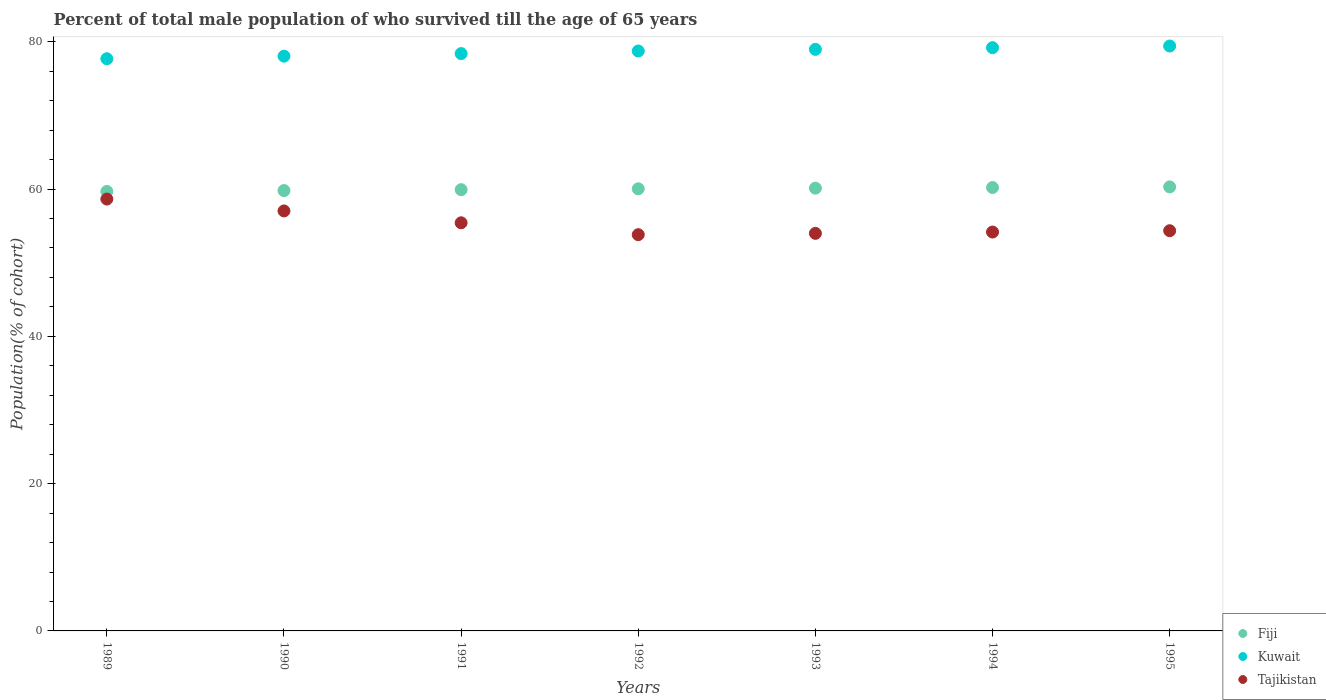How many different coloured dotlines are there?
Offer a very short reply. 3. Is the number of dotlines equal to the number of legend labels?
Your answer should be very brief. Yes. What is the percentage of total male population who survived till the age of 65 years in Kuwait in 1990?
Provide a succinct answer. 78.04. Across all years, what is the maximum percentage of total male population who survived till the age of 65 years in Kuwait?
Your answer should be compact. 79.42. Across all years, what is the minimum percentage of total male population who survived till the age of 65 years in Tajikistan?
Your answer should be compact. 53.8. In which year was the percentage of total male population who survived till the age of 65 years in Kuwait maximum?
Provide a succinct answer. 1995. What is the total percentage of total male population who survived till the age of 65 years in Kuwait in the graph?
Your answer should be compact. 550.42. What is the difference between the percentage of total male population who survived till the age of 65 years in Tajikistan in 1989 and that in 1992?
Ensure brevity in your answer.  4.84. What is the difference between the percentage of total male population who survived till the age of 65 years in Tajikistan in 1992 and the percentage of total male population who survived till the age of 65 years in Fiji in 1995?
Keep it short and to the point. -6.49. What is the average percentage of total male population who survived till the age of 65 years in Kuwait per year?
Offer a very short reply. 78.63. In the year 1989, what is the difference between the percentage of total male population who survived till the age of 65 years in Kuwait and percentage of total male population who survived till the age of 65 years in Fiji?
Your answer should be very brief. 18.02. What is the ratio of the percentage of total male population who survived till the age of 65 years in Tajikistan in 1989 to that in 1994?
Provide a succinct answer. 1.08. Is the difference between the percentage of total male population who survived till the age of 65 years in Kuwait in 1992 and 1993 greater than the difference between the percentage of total male population who survived till the age of 65 years in Fiji in 1992 and 1993?
Your answer should be compact. No. What is the difference between the highest and the second highest percentage of total male population who survived till the age of 65 years in Tajikistan?
Offer a very short reply. 1.61. What is the difference between the highest and the lowest percentage of total male population who survived till the age of 65 years in Fiji?
Your answer should be very brief. 0.62. In how many years, is the percentage of total male population who survived till the age of 65 years in Tajikistan greater than the average percentage of total male population who survived till the age of 65 years in Tajikistan taken over all years?
Ensure brevity in your answer.  3. Is the sum of the percentage of total male population who survived till the age of 65 years in Tajikistan in 1989 and 1993 greater than the maximum percentage of total male population who survived till the age of 65 years in Kuwait across all years?
Your response must be concise. Yes. Is the percentage of total male population who survived till the age of 65 years in Kuwait strictly greater than the percentage of total male population who survived till the age of 65 years in Fiji over the years?
Provide a short and direct response. Yes. How many dotlines are there?
Your answer should be compact. 3. Does the graph contain grids?
Offer a terse response. No. What is the title of the graph?
Offer a very short reply. Percent of total male population of who survived till the age of 65 years. What is the label or title of the Y-axis?
Give a very brief answer. Population(% of cohort). What is the Population(% of cohort) in Fiji in 1989?
Your answer should be very brief. 59.67. What is the Population(% of cohort) in Kuwait in 1989?
Offer a very short reply. 77.69. What is the Population(% of cohort) in Tajikistan in 1989?
Your response must be concise. 58.64. What is the Population(% of cohort) in Fiji in 1990?
Offer a very short reply. 59.79. What is the Population(% of cohort) in Kuwait in 1990?
Ensure brevity in your answer.  78.04. What is the Population(% of cohort) of Tajikistan in 1990?
Your answer should be very brief. 57.02. What is the Population(% of cohort) of Fiji in 1991?
Provide a succinct answer. 59.91. What is the Population(% of cohort) in Kuwait in 1991?
Make the answer very short. 78.39. What is the Population(% of cohort) of Tajikistan in 1991?
Offer a terse response. 55.41. What is the Population(% of cohort) of Fiji in 1992?
Provide a succinct answer. 60.03. What is the Population(% of cohort) in Kuwait in 1992?
Keep it short and to the point. 78.74. What is the Population(% of cohort) of Tajikistan in 1992?
Provide a succinct answer. 53.8. What is the Population(% of cohort) in Fiji in 1993?
Offer a terse response. 60.12. What is the Population(% of cohort) in Kuwait in 1993?
Make the answer very short. 78.96. What is the Population(% of cohort) of Tajikistan in 1993?
Your answer should be compact. 53.98. What is the Population(% of cohort) in Fiji in 1994?
Provide a succinct answer. 60.2. What is the Population(% of cohort) of Kuwait in 1994?
Give a very brief answer. 79.19. What is the Population(% of cohort) of Tajikistan in 1994?
Provide a succinct answer. 54.16. What is the Population(% of cohort) in Fiji in 1995?
Make the answer very short. 60.29. What is the Population(% of cohort) in Kuwait in 1995?
Your answer should be very brief. 79.42. What is the Population(% of cohort) of Tajikistan in 1995?
Ensure brevity in your answer.  54.34. Across all years, what is the maximum Population(% of cohort) in Fiji?
Keep it short and to the point. 60.29. Across all years, what is the maximum Population(% of cohort) in Kuwait?
Your answer should be compact. 79.42. Across all years, what is the maximum Population(% of cohort) in Tajikistan?
Ensure brevity in your answer.  58.64. Across all years, what is the minimum Population(% of cohort) in Fiji?
Provide a short and direct response. 59.67. Across all years, what is the minimum Population(% of cohort) in Kuwait?
Your response must be concise. 77.69. Across all years, what is the minimum Population(% of cohort) in Tajikistan?
Your response must be concise. 53.8. What is the total Population(% of cohort) in Fiji in the graph?
Keep it short and to the point. 420.01. What is the total Population(% of cohort) in Kuwait in the graph?
Offer a very short reply. 550.42. What is the total Population(% of cohort) of Tajikistan in the graph?
Your answer should be very brief. 387.35. What is the difference between the Population(% of cohort) of Fiji in 1989 and that in 1990?
Your answer should be compact. -0.12. What is the difference between the Population(% of cohort) of Kuwait in 1989 and that in 1990?
Your response must be concise. -0.35. What is the difference between the Population(% of cohort) of Tajikistan in 1989 and that in 1990?
Your answer should be very brief. 1.61. What is the difference between the Population(% of cohort) in Fiji in 1989 and that in 1991?
Make the answer very short. -0.24. What is the difference between the Population(% of cohort) in Kuwait in 1989 and that in 1991?
Provide a succinct answer. -0.7. What is the difference between the Population(% of cohort) in Tajikistan in 1989 and that in 1991?
Your response must be concise. 3.22. What is the difference between the Population(% of cohort) in Fiji in 1989 and that in 1992?
Keep it short and to the point. -0.36. What is the difference between the Population(% of cohort) in Kuwait in 1989 and that in 1992?
Provide a short and direct response. -1.05. What is the difference between the Population(% of cohort) in Tajikistan in 1989 and that in 1992?
Make the answer very short. 4.84. What is the difference between the Population(% of cohort) of Fiji in 1989 and that in 1993?
Offer a terse response. -0.45. What is the difference between the Population(% of cohort) in Kuwait in 1989 and that in 1993?
Offer a terse response. -1.27. What is the difference between the Population(% of cohort) in Tajikistan in 1989 and that in 1993?
Make the answer very short. 4.66. What is the difference between the Population(% of cohort) in Fiji in 1989 and that in 1994?
Make the answer very short. -0.53. What is the difference between the Population(% of cohort) of Kuwait in 1989 and that in 1994?
Make the answer very short. -1.5. What is the difference between the Population(% of cohort) of Tajikistan in 1989 and that in 1994?
Offer a very short reply. 4.48. What is the difference between the Population(% of cohort) in Fiji in 1989 and that in 1995?
Offer a very short reply. -0.62. What is the difference between the Population(% of cohort) in Kuwait in 1989 and that in 1995?
Keep it short and to the point. -1.73. What is the difference between the Population(% of cohort) in Tajikistan in 1989 and that in 1995?
Ensure brevity in your answer.  4.3. What is the difference between the Population(% of cohort) of Fiji in 1990 and that in 1991?
Provide a succinct answer. -0.12. What is the difference between the Population(% of cohort) of Kuwait in 1990 and that in 1991?
Keep it short and to the point. -0.35. What is the difference between the Population(% of cohort) in Tajikistan in 1990 and that in 1991?
Offer a very short reply. 1.61. What is the difference between the Population(% of cohort) of Fiji in 1990 and that in 1992?
Provide a succinct answer. -0.24. What is the difference between the Population(% of cohort) of Kuwait in 1990 and that in 1992?
Provide a short and direct response. -0.7. What is the difference between the Population(% of cohort) of Tajikistan in 1990 and that in 1992?
Your answer should be compact. 3.22. What is the difference between the Population(% of cohort) in Fiji in 1990 and that in 1993?
Offer a terse response. -0.33. What is the difference between the Population(% of cohort) of Kuwait in 1990 and that in 1993?
Provide a succinct answer. -0.93. What is the difference between the Population(% of cohort) in Tajikistan in 1990 and that in 1993?
Your answer should be very brief. 3.04. What is the difference between the Population(% of cohort) of Fiji in 1990 and that in 1994?
Give a very brief answer. -0.41. What is the difference between the Population(% of cohort) in Kuwait in 1990 and that in 1994?
Your answer should be compact. -1.15. What is the difference between the Population(% of cohort) of Tajikistan in 1990 and that in 1994?
Offer a terse response. 2.87. What is the difference between the Population(% of cohort) of Kuwait in 1990 and that in 1995?
Ensure brevity in your answer.  -1.38. What is the difference between the Population(% of cohort) of Tajikistan in 1990 and that in 1995?
Make the answer very short. 2.69. What is the difference between the Population(% of cohort) of Fiji in 1991 and that in 1992?
Give a very brief answer. -0.12. What is the difference between the Population(% of cohort) in Kuwait in 1991 and that in 1992?
Ensure brevity in your answer.  -0.35. What is the difference between the Population(% of cohort) in Tajikistan in 1991 and that in 1992?
Offer a very short reply. 1.61. What is the difference between the Population(% of cohort) of Fiji in 1991 and that in 1993?
Your answer should be very brief. -0.21. What is the difference between the Population(% of cohort) in Kuwait in 1991 and that in 1993?
Your answer should be compact. -0.58. What is the difference between the Population(% of cohort) in Tajikistan in 1991 and that in 1993?
Offer a terse response. 1.43. What is the difference between the Population(% of cohort) of Fiji in 1991 and that in 1994?
Provide a short and direct response. -0.29. What is the difference between the Population(% of cohort) in Kuwait in 1991 and that in 1994?
Offer a very short reply. -0.8. What is the difference between the Population(% of cohort) of Tajikistan in 1991 and that in 1994?
Ensure brevity in your answer.  1.25. What is the difference between the Population(% of cohort) in Fiji in 1991 and that in 1995?
Your answer should be very brief. -0.38. What is the difference between the Population(% of cohort) of Kuwait in 1991 and that in 1995?
Provide a short and direct response. -1.03. What is the difference between the Population(% of cohort) in Tajikistan in 1991 and that in 1995?
Offer a terse response. 1.07. What is the difference between the Population(% of cohort) of Fiji in 1992 and that in 1993?
Keep it short and to the point. -0.09. What is the difference between the Population(% of cohort) of Kuwait in 1992 and that in 1993?
Offer a terse response. -0.23. What is the difference between the Population(% of cohort) of Tajikistan in 1992 and that in 1993?
Provide a succinct answer. -0.18. What is the difference between the Population(% of cohort) of Fiji in 1992 and that in 1994?
Offer a terse response. -0.17. What is the difference between the Population(% of cohort) of Kuwait in 1992 and that in 1994?
Provide a short and direct response. -0.45. What is the difference between the Population(% of cohort) of Tajikistan in 1992 and that in 1994?
Offer a very short reply. -0.36. What is the difference between the Population(% of cohort) of Fiji in 1992 and that in 1995?
Give a very brief answer. -0.26. What is the difference between the Population(% of cohort) of Kuwait in 1992 and that in 1995?
Make the answer very short. -0.68. What is the difference between the Population(% of cohort) of Tajikistan in 1992 and that in 1995?
Make the answer very short. -0.54. What is the difference between the Population(% of cohort) of Fiji in 1993 and that in 1994?
Your answer should be compact. -0.09. What is the difference between the Population(% of cohort) in Kuwait in 1993 and that in 1994?
Your answer should be very brief. -0.23. What is the difference between the Population(% of cohort) in Tajikistan in 1993 and that in 1994?
Make the answer very short. -0.18. What is the difference between the Population(% of cohort) in Fiji in 1993 and that in 1995?
Provide a short and direct response. -0.17. What is the difference between the Population(% of cohort) of Kuwait in 1993 and that in 1995?
Provide a succinct answer. -0.45. What is the difference between the Population(% of cohort) of Tajikistan in 1993 and that in 1995?
Your answer should be compact. -0.36. What is the difference between the Population(% of cohort) in Fiji in 1994 and that in 1995?
Your answer should be very brief. -0.09. What is the difference between the Population(% of cohort) in Kuwait in 1994 and that in 1995?
Your answer should be compact. -0.23. What is the difference between the Population(% of cohort) of Tajikistan in 1994 and that in 1995?
Your answer should be very brief. -0.18. What is the difference between the Population(% of cohort) in Fiji in 1989 and the Population(% of cohort) in Kuwait in 1990?
Keep it short and to the point. -18.37. What is the difference between the Population(% of cohort) in Fiji in 1989 and the Population(% of cohort) in Tajikistan in 1990?
Keep it short and to the point. 2.64. What is the difference between the Population(% of cohort) of Kuwait in 1989 and the Population(% of cohort) of Tajikistan in 1990?
Your answer should be very brief. 20.66. What is the difference between the Population(% of cohort) in Fiji in 1989 and the Population(% of cohort) in Kuwait in 1991?
Provide a succinct answer. -18.72. What is the difference between the Population(% of cohort) in Fiji in 1989 and the Population(% of cohort) in Tajikistan in 1991?
Give a very brief answer. 4.26. What is the difference between the Population(% of cohort) in Kuwait in 1989 and the Population(% of cohort) in Tajikistan in 1991?
Your response must be concise. 22.28. What is the difference between the Population(% of cohort) in Fiji in 1989 and the Population(% of cohort) in Kuwait in 1992?
Your answer should be very brief. -19.07. What is the difference between the Population(% of cohort) of Fiji in 1989 and the Population(% of cohort) of Tajikistan in 1992?
Keep it short and to the point. 5.87. What is the difference between the Population(% of cohort) of Kuwait in 1989 and the Population(% of cohort) of Tajikistan in 1992?
Offer a terse response. 23.89. What is the difference between the Population(% of cohort) in Fiji in 1989 and the Population(% of cohort) in Kuwait in 1993?
Give a very brief answer. -19.29. What is the difference between the Population(% of cohort) of Fiji in 1989 and the Population(% of cohort) of Tajikistan in 1993?
Your response must be concise. 5.69. What is the difference between the Population(% of cohort) in Kuwait in 1989 and the Population(% of cohort) in Tajikistan in 1993?
Ensure brevity in your answer.  23.71. What is the difference between the Population(% of cohort) in Fiji in 1989 and the Population(% of cohort) in Kuwait in 1994?
Offer a very short reply. -19.52. What is the difference between the Population(% of cohort) of Fiji in 1989 and the Population(% of cohort) of Tajikistan in 1994?
Make the answer very short. 5.51. What is the difference between the Population(% of cohort) in Kuwait in 1989 and the Population(% of cohort) in Tajikistan in 1994?
Ensure brevity in your answer.  23.53. What is the difference between the Population(% of cohort) of Fiji in 1989 and the Population(% of cohort) of Kuwait in 1995?
Give a very brief answer. -19.75. What is the difference between the Population(% of cohort) of Fiji in 1989 and the Population(% of cohort) of Tajikistan in 1995?
Keep it short and to the point. 5.33. What is the difference between the Population(% of cohort) of Kuwait in 1989 and the Population(% of cohort) of Tajikistan in 1995?
Keep it short and to the point. 23.35. What is the difference between the Population(% of cohort) in Fiji in 1990 and the Population(% of cohort) in Kuwait in 1991?
Your answer should be compact. -18.6. What is the difference between the Population(% of cohort) in Fiji in 1990 and the Population(% of cohort) in Tajikistan in 1991?
Make the answer very short. 4.38. What is the difference between the Population(% of cohort) in Kuwait in 1990 and the Population(% of cohort) in Tajikistan in 1991?
Your answer should be very brief. 22.63. What is the difference between the Population(% of cohort) of Fiji in 1990 and the Population(% of cohort) of Kuwait in 1992?
Make the answer very short. -18.95. What is the difference between the Population(% of cohort) of Fiji in 1990 and the Population(% of cohort) of Tajikistan in 1992?
Give a very brief answer. 5.99. What is the difference between the Population(% of cohort) of Kuwait in 1990 and the Population(% of cohort) of Tajikistan in 1992?
Your answer should be compact. 24.24. What is the difference between the Population(% of cohort) of Fiji in 1990 and the Population(% of cohort) of Kuwait in 1993?
Offer a terse response. -19.17. What is the difference between the Population(% of cohort) in Fiji in 1990 and the Population(% of cohort) in Tajikistan in 1993?
Your answer should be very brief. 5.81. What is the difference between the Population(% of cohort) of Kuwait in 1990 and the Population(% of cohort) of Tajikistan in 1993?
Offer a very short reply. 24.06. What is the difference between the Population(% of cohort) in Fiji in 1990 and the Population(% of cohort) in Kuwait in 1994?
Make the answer very short. -19.4. What is the difference between the Population(% of cohort) of Fiji in 1990 and the Population(% of cohort) of Tajikistan in 1994?
Keep it short and to the point. 5.63. What is the difference between the Population(% of cohort) in Kuwait in 1990 and the Population(% of cohort) in Tajikistan in 1994?
Offer a very short reply. 23.88. What is the difference between the Population(% of cohort) of Fiji in 1990 and the Population(% of cohort) of Kuwait in 1995?
Make the answer very short. -19.63. What is the difference between the Population(% of cohort) in Fiji in 1990 and the Population(% of cohort) in Tajikistan in 1995?
Ensure brevity in your answer.  5.45. What is the difference between the Population(% of cohort) of Kuwait in 1990 and the Population(% of cohort) of Tajikistan in 1995?
Provide a succinct answer. 23.7. What is the difference between the Population(% of cohort) of Fiji in 1991 and the Population(% of cohort) of Kuwait in 1992?
Your answer should be very brief. -18.83. What is the difference between the Population(% of cohort) of Fiji in 1991 and the Population(% of cohort) of Tajikistan in 1992?
Make the answer very short. 6.11. What is the difference between the Population(% of cohort) in Kuwait in 1991 and the Population(% of cohort) in Tajikistan in 1992?
Keep it short and to the point. 24.59. What is the difference between the Population(% of cohort) in Fiji in 1991 and the Population(% of cohort) in Kuwait in 1993?
Offer a very short reply. -19.05. What is the difference between the Population(% of cohort) in Fiji in 1991 and the Population(% of cohort) in Tajikistan in 1993?
Your answer should be compact. 5.93. What is the difference between the Population(% of cohort) in Kuwait in 1991 and the Population(% of cohort) in Tajikistan in 1993?
Keep it short and to the point. 24.41. What is the difference between the Population(% of cohort) of Fiji in 1991 and the Population(% of cohort) of Kuwait in 1994?
Provide a succinct answer. -19.28. What is the difference between the Population(% of cohort) in Fiji in 1991 and the Population(% of cohort) in Tajikistan in 1994?
Make the answer very short. 5.75. What is the difference between the Population(% of cohort) of Kuwait in 1991 and the Population(% of cohort) of Tajikistan in 1994?
Provide a succinct answer. 24.23. What is the difference between the Population(% of cohort) of Fiji in 1991 and the Population(% of cohort) of Kuwait in 1995?
Ensure brevity in your answer.  -19.51. What is the difference between the Population(% of cohort) of Fiji in 1991 and the Population(% of cohort) of Tajikistan in 1995?
Offer a terse response. 5.57. What is the difference between the Population(% of cohort) of Kuwait in 1991 and the Population(% of cohort) of Tajikistan in 1995?
Ensure brevity in your answer.  24.05. What is the difference between the Population(% of cohort) in Fiji in 1992 and the Population(% of cohort) in Kuwait in 1993?
Provide a succinct answer. -18.93. What is the difference between the Population(% of cohort) of Fiji in 1992 and the Population(% of cohort) of Tajikistan in 1993?
Your answer should be very brief. 6.05. What is the difference between the Population(% of cohort) of Kuwait in 1992 and the Population(% of cohort) of Tajikistan in 1993?
Provide a succinct answer. 24.76. What is the difference between the Population(% of cohort) in Fiji in 1992 and the Population(% of cohort) in Kuwait in 1994?
Offer a terse response. -19.16. What is the difference between the Population(% of cohort) of Fiji in 1992 and the Population(% of cohort) of Tajikistan in 1994?
Make the answer very short. 5.87. What is the difference between the Population(% of cohort) in Kuwait in 1992 and the Population(% of cohort) in Tajikistan in 1994?
Keep it short and to the point. 24.58. What is the difference between the Population(% of cohort) of Fiji in 1992 and the Population(% of cohort) of Kuwait in 1995?
Make the answer very short. -19.39. What is the difference between the Population(% of cohort) in Fiji in 1992 and the Population(% of cohort) in Tajikistan in 1995?
Offer a very short reply. 5.69. What is the difference between the Population(% of cohort) of Kuwait in 1992 and the Population(% of cohort) of Tajikistan in 1995?
Provide a succinct answer. 24.4. What is the difference between the Population(% of cohort) of Fiji in 1993 and the Population(% of cohort) of Kuwait in 1994?
Offer a terse response. -19.07. What is the difference between the Population(% of cohort) in Fiji in 1993 and the Population(% of cohort) in Tajikistan in 1994?
Your response must be concise. 5.96. What is the difference between the Population(% of cohort) of Kuwait in 1993 and the Population(% of cohort) of Tajikistan in 1994?
Provide a succinct answer. 24.8. What is the difference between the Population(% of cohort) in Fiji in 1993 and the Population(% of cohort) in Kuwait in 1995?
Your answer should be very brief. -19.3. What is the difference between the Population(% of cohort) of Fiji in 1993 and the Population(% of cohort) of Tajikistan in 1995?
Ensure brevity in your answer.  5.78. What is the difference between the Population(% of cohort) in Kuwait in 1993 and the Population(% of cohort) in Tajikistan in 1995?
Your answer should be very brief. 24.62. What is the difference between the Population(% of cohort) of Fiji in 1994 and the Population(% of cohort) of Kuwait in 1995?
Keep it short and to the point. -19.21. What is the difference between the Population(% of cohort) in Fiji in 1994 and the Population(% of cohort) in Tajikistan in 1995?
Your response must be concise. 5.86. What is the difference between the Population(% of cohort) in Kuwait in 1994 and the Population(% of cohort) in Tajikistan in 1995?
Provide a succinct answer. 24.85. What is the average Population(% of cohort) in Fiji per year?
Your answer should be compact. 60. What is the average Population(% of cohort) in Kuwait per year?
Offer a very short reply. 78.63. What is the average Population(% of cohort) in Tajikistan per year?
Ensure brevity in your answer.  55.34. In the year 1989, what is the difference between the Population(% of cohort) of Fiji and Population(% of cohort) of Kuwait?
Offer a terse response. -18.02. In the year 1989, what is the difference between the Population(% of cohort) of Fiji and Population(% of cohort) of Tajikistan?
Offer a terse response. 1.03. In the year 1989, what is the difference between the Population(% of cohort) of Kuwait and Population(% of cohort) of Tajikistan?
Keep it short and to the point. 19.05. In the year 1990, what is the difference between the Population(% of cohort) in Fiji and Population(% of cohort) in Kuwait?
Your response must be concise. -18.25. In the year 1990, what is the difference between the Population(% of cohort) in Fiji and Population(% of cohort) in Tajikistan?
Offer a terse response. 2.76. In the year 1990, what is the difference between the Population(% of cohort) of Kuwait and Population(% of cohort) of Tajikistan?
Keep it short and to the point. 21.01. In the year 1991, what is the difference between the Population(% of cohort) in Fiji and Population(% of cohort) in Kuwait?
Your answer should be very brief. -18.48. In the year 1991, what is the difference between the Population(% of cohort) in Fiji and Population(% of cohort) in Tajikistan?
Offer a terse response. 4.5. In the year 1991, what is the difference between the Population(% of cohort) of Kuwait and Population(% of cohort) of Tajikistan?
Provide a succinct answer. 22.97. In the year 1992, what is the difference between the Population(% of cohort) in Fiji and Population(% of cohort) in Kuwait?
Your answer should be very brief. -18.71. In the year 1992, what is the difference between the Population(% of cohort) in Fiji and Population(% of cohort) in Tajikistan?
Keep it short and to the point. 6.23. In the year 1992, what is the difference between the Population(% of cohort) of Kuwait and Population(% of cohort) of Tajikistan?
Your response must be concise. 24.94. In the year 1993, what is the difference between the Population(% of cohort) of Fiji and Population(% of cohort) of Kuwait?
Give a very brief answer. -18.85. In the year 1993, what is the difference between the Population(% of cohort) in Fiji and Population(% of cohort) in Tajikistan?
Provide a succinct answer. 6.14. In the year 1993, what is the difference between the Population(% of cohort) of Kuwait and Population(% of cohort) of Tajikistan?
Your answer should be compact. 24.98. In the year 1994, what is the difference between the Population(% of cohort) of Fiji and Population(% of cohort) of Kuwait?
Offer a terse response. -18.99. In the year 1994, what is the difference between the Population(% of cohort) in Fiji and Population(% of cohort) in Tajikistan?
Your answer should be very brief. 6.04. In the year 1994, what is the difference between the Population(% of cohort) in Kuwait and Population(% of cohort) in Tajikistan?
Your answer should be compact. 25.03. In the year 1995, what is the difference between the Population(% of cohort) in Fiji and Population(% of cohort) in Kuwait?
Your answer should be very brief. -19.13. In the year 1995, what is the difference between the Population(% of cohort) of Fiji and Population(% of cohort) of Tajikistan?
Your answer should be very brief. 5.95. In the year 1995, what is the difference between the Population(% of cohort) in Kuwait and Population(% of cohort) in Tajikistan?
Provide a short and direct response. 25.08. What is the ratio of the Population(% of cohort) of Kuwait in 1989 to that in 1990?
Give a very brief answer. 1. What is the ratio of the Population(% of cohort) in Tajikistan in 1989 to that in 1990?
Provide a succinct answer. 1.03. What is the ratio of the Population(% of cohort) in Fiji in 1989 to that in 1991?
Offer a terse response. 1. What is the ratio of the Population(% of cohort) in Tajikistan in 1989 to that in 1991?
Keep it short and to the point. 1.06. What is the ratio of the Population(% of cohort) of Fiji in 1989 to that in 1992?
Your answer should be compact. 0.99. What is the ratio of the Population(% of cohort) in Kuwait in 1989 to that in 1992?
Offer a very short reply. 0.99. What is the ratio of the Population(% of cohort) of Tajikistan in 1989 to that in 1992?
Offer a terse response. 1.09. What is the ratio of the Population(% of cohort) in Kuwait in 1989 to that in 1993?
Give a very brief answer. 0.98. What is the ratio of the Population(% of cohort) of Tajikistan in 1989 to that in 1993?
Ensure brevity in your answer.  1.09. What is the ratio of the Population(% of cohort) in Kuwait in 1989 to that in 1994?
Provide a succinct answer. 0.98. What is the ratio of the Population(% of cohort) in Tajikistan in 1989 to that in 1994?
Provide a succinct answer. 1.08. What is the ratio of the Population(% of cohort) in Kuwait in 1989 to that in 1995?
Your answer should be compact. 0.98. What is the ratio of the Population(% of cohort) of Tajikistan in 1989 to that in 1995?
Provide a short and direct response. 1.08. What is the ratio of the Population(% of cohort) in Fiji in 1990 to that in 1991?
Provide a succinct answer. 1. What is the ratio of the Population(% of cohort) of Kuwait in 1990 to that in 1991?
Make the answer very short. 1. What is the ratio of the Population(% of cohort) in Tajikistan in 1990 to that in 1991?
Your answer should be very brief. 1.03. What is the ratio of the Population(% of cohort) of Fiji in 1990 to that in 1992?
Offer a very short reply. 1. What is the ratio of the Population(% of cohort) of Kuwait in 1990 to that in 1992?
Your answer should be very brief. 0.99. What is the ratio of the Population(% of cohort) in Tajikistan in 1990 to that in 1992?
Offer a very short reply. 1.06. What is the ratio of the Population(% of cohort) of Kuwait in 1990 to that in 1993?
Your answer should be very brief. 0.99. What is the ratio of the Population(% of cohort) of Tajikistan in 1990 to that in 1993?
Your response must be concise. 1.06. What is the ratio of the Population(% of cohort) of Fiji in 1990 to that in 1994?
Make the answer very short. 0.99. What is the ratio of the Population(% of cohort) of Kuwait in 1990 to that in 1994?
Your answer should be very brief. 0.99. What is the ratio of the Population(% of cohort) in Tajikistan in 1990 to that in 1994?
Provide a succinct answer. 1.05. What is the ratio of the Population(% of cohort) in Kuwait in 1990 to that in 1995?
Your answer should be compact. 0.98. What is the ratio of the Population(% of cohort) in Tajikistan in 1990 to that in 1995?
Give a very brief answer. 1.05. What is the ratio of the Population(% of cohort) of Fiji in 1991 to that in 1992?
Give a very brief answer. 1. What is the ratio of the Population(% of cohort) in Kuwait in 1991 to that in 1992?
Provide a succinct answer. 1. What is the ratio of the Population(% of cohort) of Tajikistan in 1991 to that in 1993?
Provide a succinct answer. 1.03. What is the ratio of the Population(% of cohort) in Kuwait in 1991 to that in 1994?
Provide a succinct answer. 0.99. What is the ratio of the Population(% of cohort) in Tajikistan in 1991 to that in 1994?
Your answer should be compact. 1.02. What is the ratio of the Population(% of cohort) of Fiji in 1991 to that in 1995?
Ensure brevity in your answer.  0.99. What is the ratio of the Population(% of cohort) of Kuwait in 1991 to that in 1995?
Your answer should be very brief. 0.99. What is the ratio of the Population(% of cohort) of Tajikistan in 1991 to that in 1995?
Make the answer very short. 1.02. What is the ratio of the Population(% of cohort) in Fiji in 1992 to that in 1993?
Provide a succinct answer. 1. What is the ratio of the Population(% of cohort) in Kuwait in 1992 to that in 1993?
Provide a short and direct response. 1. What is the ratio of the Population(% of cohort) of Tajikistan in 1992 to that in 1993?
Provide a succinct answer. 1. What is the ratio of the Population(% of cohort) in Tajikistan in 1992 to that in 1994?
Offer a very short reply. 0.99. What is the ratio of the Population(% of cohort) of Kuwait in 1992 to that in 1995?
Ensure brevity in your answer.  0.99. What is the ratio of the Population(% of cohort) in Kuwait in 1993 to that in 1995?
Keep it short and to the point. 0.99. What is the ratio of the Population(% of cohort) of Kuwait in 1994 to that in 1995?
Give a very brief answer. 1. What is the difference between the highest and the second highest Population(% of cohort) of Fiji?
Ensure brevity in your answer.  0.09. What is the difference between the highest and the second highest Population(% of cohort) in Kuwait?
Your answer should be compact. 0.23. What is the difference between the highest and the second highest Population(% of cohort) in Tajikistan?
Offer a terse response. 1.61. What is the difference between the highest and the lowest Population(% of cohort) of Fiji?
Your answer should be compact. 0.62. What is the difference between the highest and the lowest Population(% of cohort) of Kuwait?
Give a very brief answer. 1.73. What is the difference between the highest and the lowest Population(% of cohort) in Tajikistan?
Offer a terse response. 4.84. 